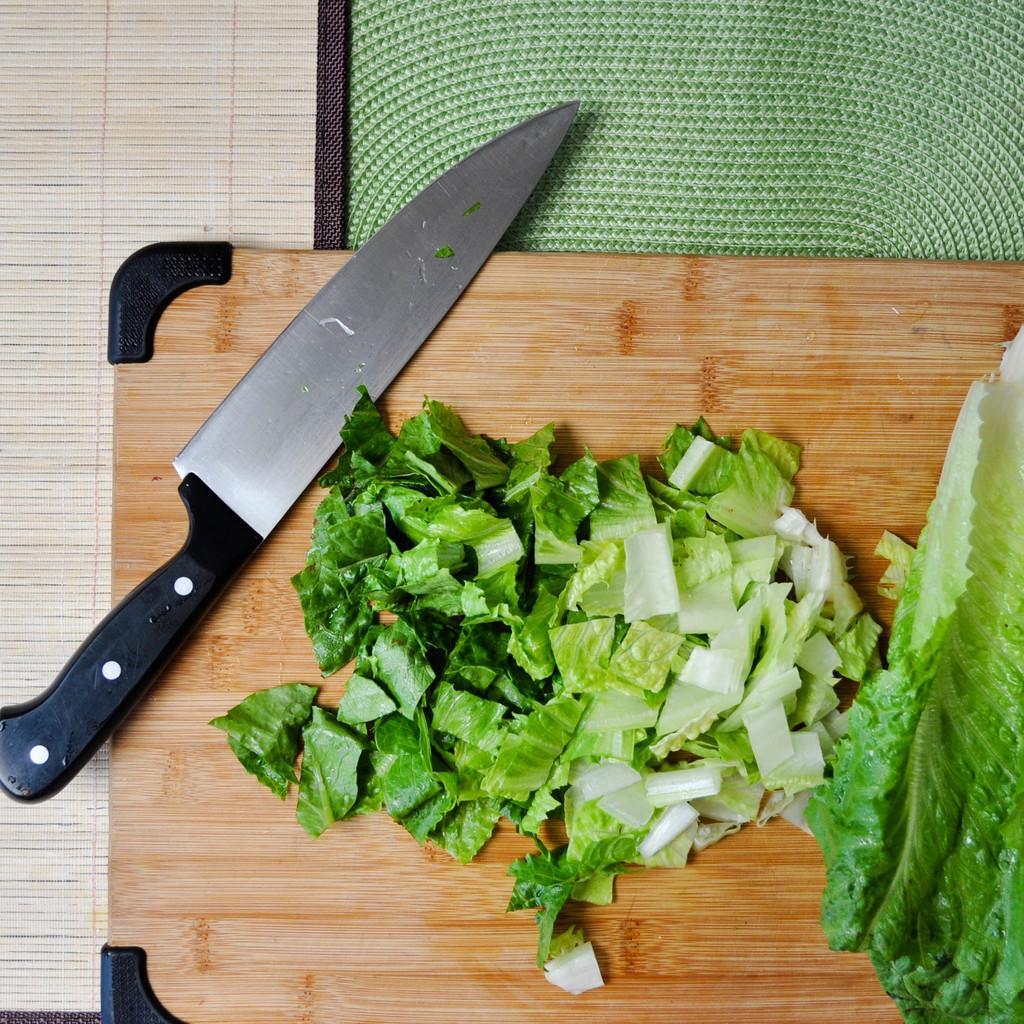Please provide a concise description of this image. Here I can see a cutting board on which a knife is placed and also I can see a leaf cut into pieces. At the top there is a mat. In the background there is a wooden surface. 